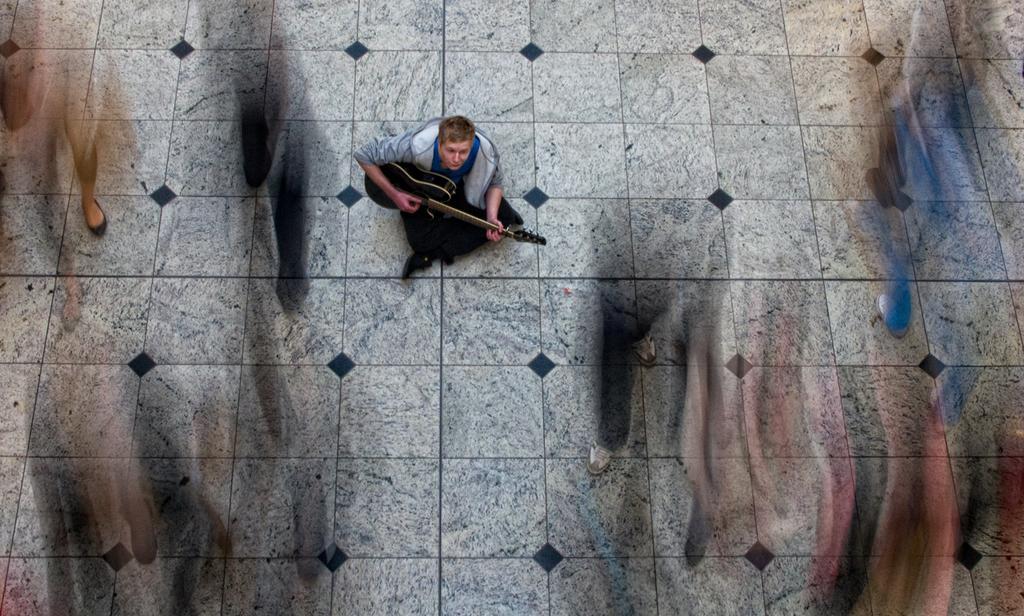Describe this image in one or two sentences. In this image there is a man sitting on the floor, he is playing a musical instrument, there are persons walking on the floor, the persons are blurred. 